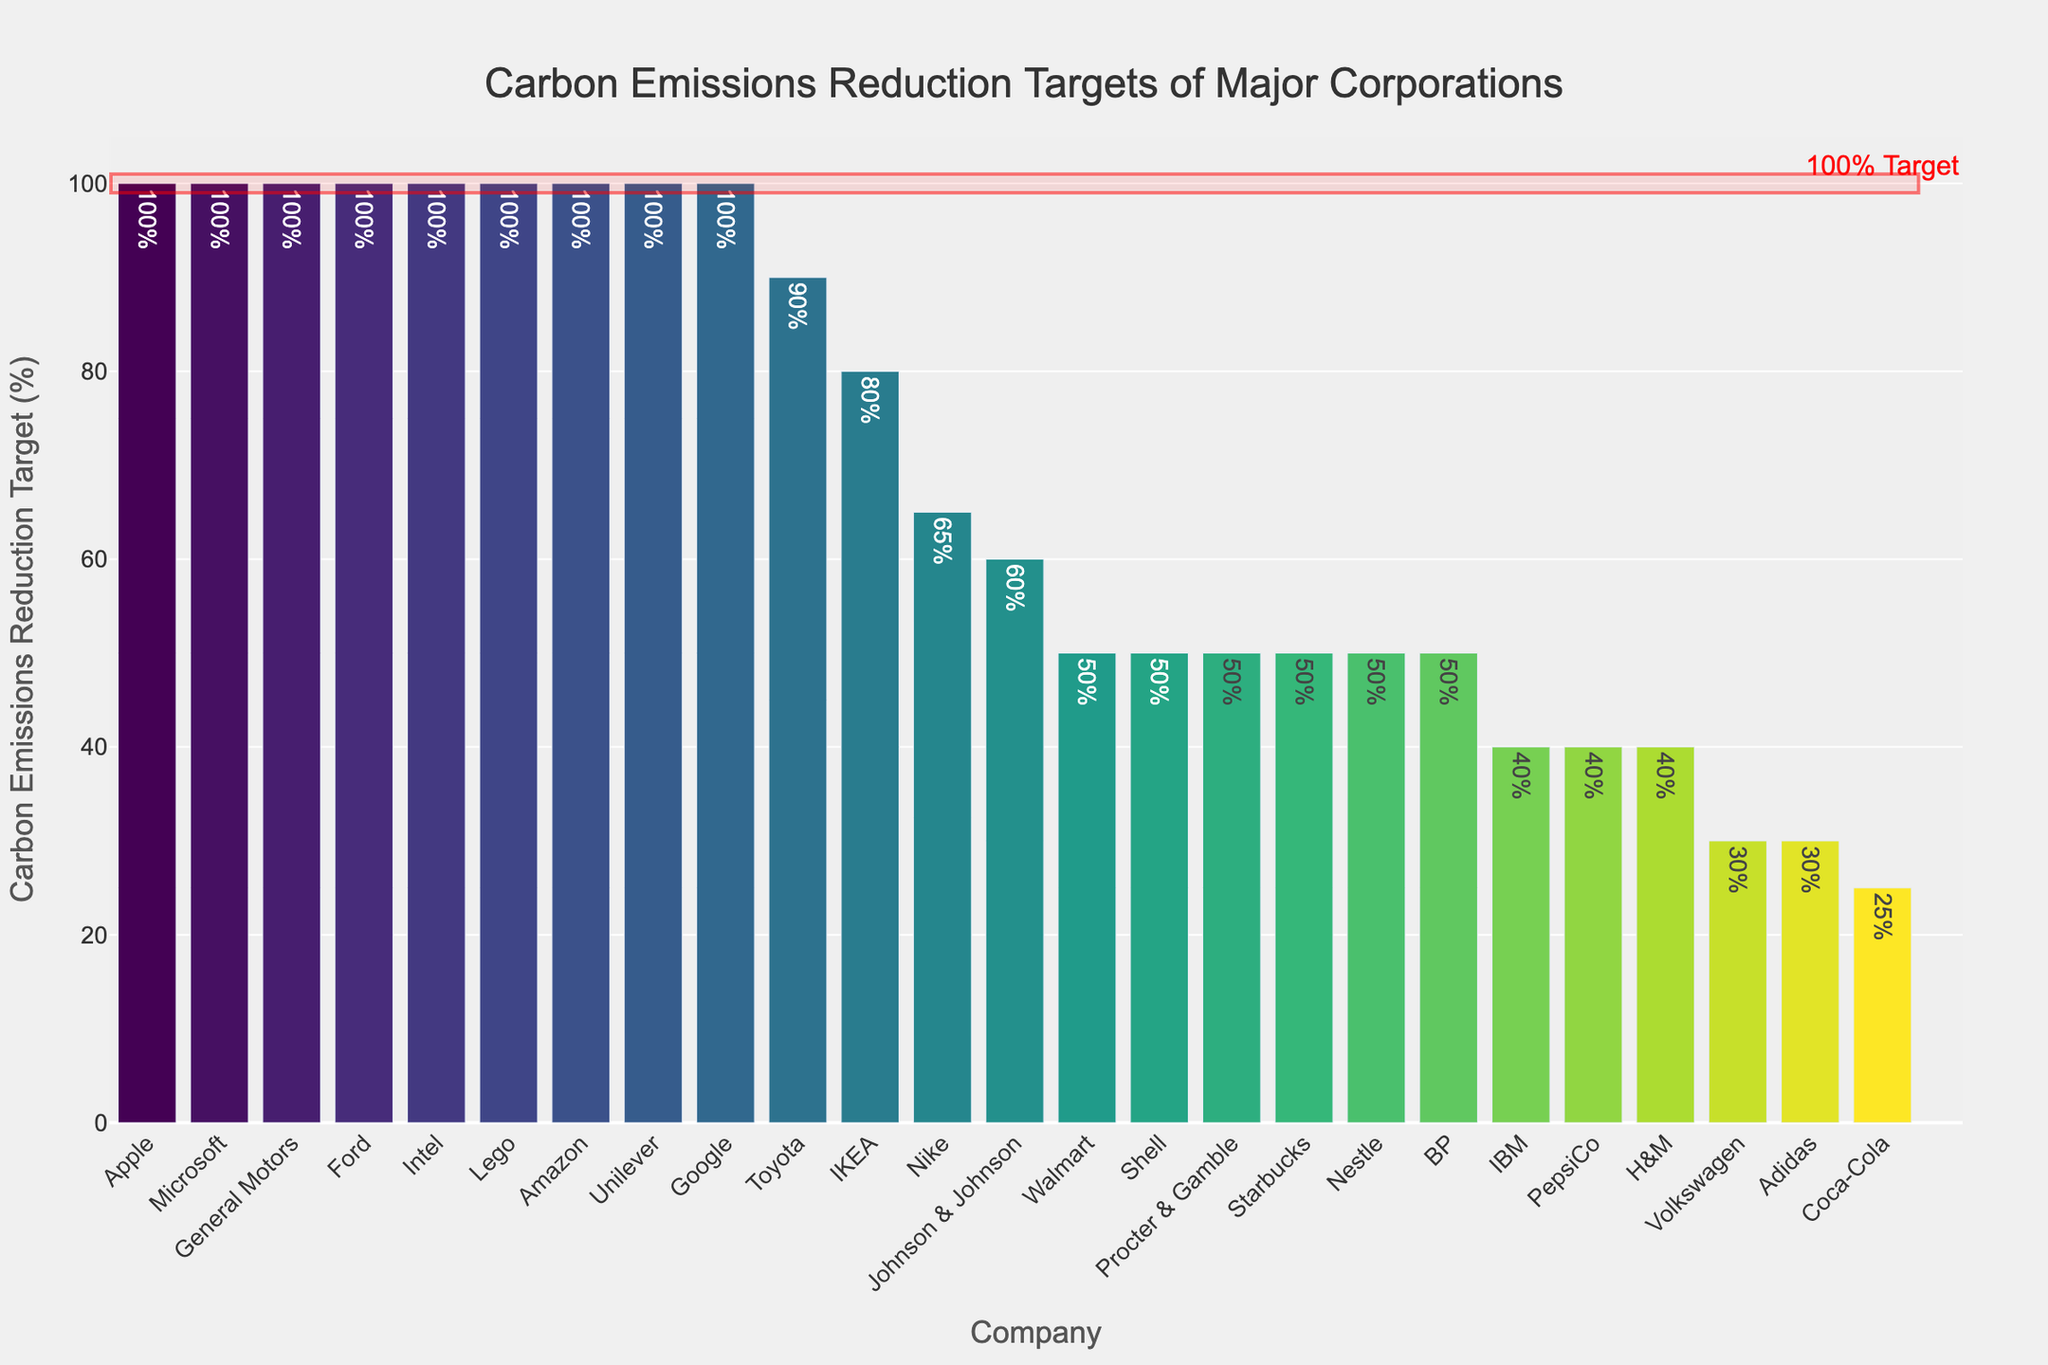Which company has the lowest carbon emissions reduction target? The company with the lowest bar in the chart represents the lowest carbon emissions reduction target. Coca-Cola's bar is the shortest, signifying the lowest target.
Answer: Coca-Cola Which companies have a 100% carbon emissions reduction target? By identifying the companies whose bars align with the 100% mark and are enclosed within the highlighted rectangle, we see multiple companies. These include Apple, Microsoft, Google, Amazon, Unilever, Intel, Ford, General Motors, and Lego.
Answer: Apple, Microsoft, Google, Amazon, Unilever, Intel, Ford, General Motors, Lego How many companies have a target of 50%? By counting the number of bars that reach the 50% mark on the y-axis, we identify those companies. The bars at the 50% level belong to Walmart, BP, Shell, Nestle, Procter & Gamble, and Starbucks. Thus, there are six companies.
Answer: 6 What is the average carbon emissions reduction target of Amazon, Walmart, and IKEA? Find Amazon, Walmart, and IKEA on the x-axis. Amazon has 100%, Walmart has 50%, and IKEA has 80%. Sum these targets (100 + 50 + 80 = 230) and divide by the number of companies (3). So, 230 / 3 = 76.67%.
Answer: 76.67% Which company has a higher carbon emissions reduction target, PepsiCo or IBM? Locate PepsiCo and IBM on the x-axis. PepsiCo's bar reaches the 40% mark, whereas IBM's bar also reaches the 40% mark. Both companies have the same target.
Answer: They have the same target Among the companies with targets below 60%, which one has the highest target? Identify the companies with bars below the 60% mark. Among these, Johnson & Johnson has the highest bar, reaching 60%.
Answer: Johnson & Johnson What's the difference in carbon emissions reduction target between Toyota and Volkswagen? Find the target percentage for Toyota (90%) and Volkswagen (30%). Subtract the two values (90 - 30). The difference is 60%.
Answer: 60% Which two companies have the same carbon emissions reduction target of 100%, and belong to the technology sector? Identify companies within the technology sector and compare their targets. Apple, Microsoft, Google, Amazon, Intel, and IBM are technology companies. Among them, Apple, Microsoft, Google, Amazon, and Intel have a 100% target. Select two, for example, Apple and Microsoft.
Answer: Apple, Microsoft What is the proportion of companies with a 100% target compared to the total number of companies? Count the number of companies with a 100% target (9) and the total number of companies (25). Divide the former by the latter (9/25) and then multiply by 100 to get the percentage. The proportion is 36%.
Answer: 36% Do more companies have targets above or below 50%? Count the number of companies with targets above 50% and those with targets below 50%. There are 12 companies above 50% and 13 companies below 50%. More companies have targets below 50%.
Answer: Below 50% 